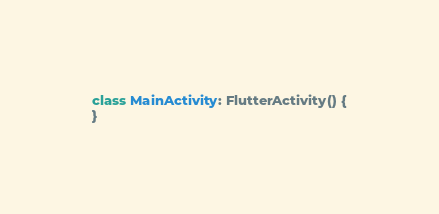<code> <loc_0><loc_0><loc_500><loc_500><_Kotlin_>
class MainActivity: FlutterActivity() {
}
</code> 